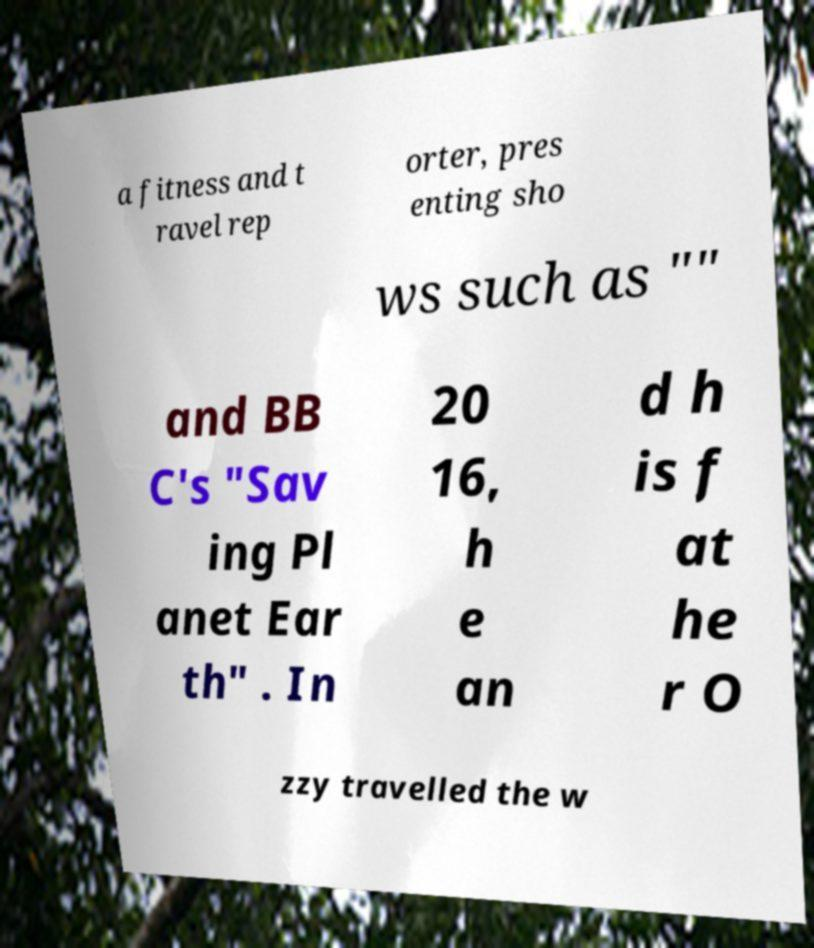Please identify and transcribe the text found in this image. a fitness and t ravel rep orter, pres enting sho ws such as "" and BB C's "Sav ing Pl anet Ear th" . In 20 16, h e an d h is f at he r O zzy travelled the w 